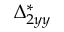Convert formula to latex. <formula><loc_0><loc_0><loc_500><loc_500>\Delta _ { 2 y y } ^ { * }</formula> 